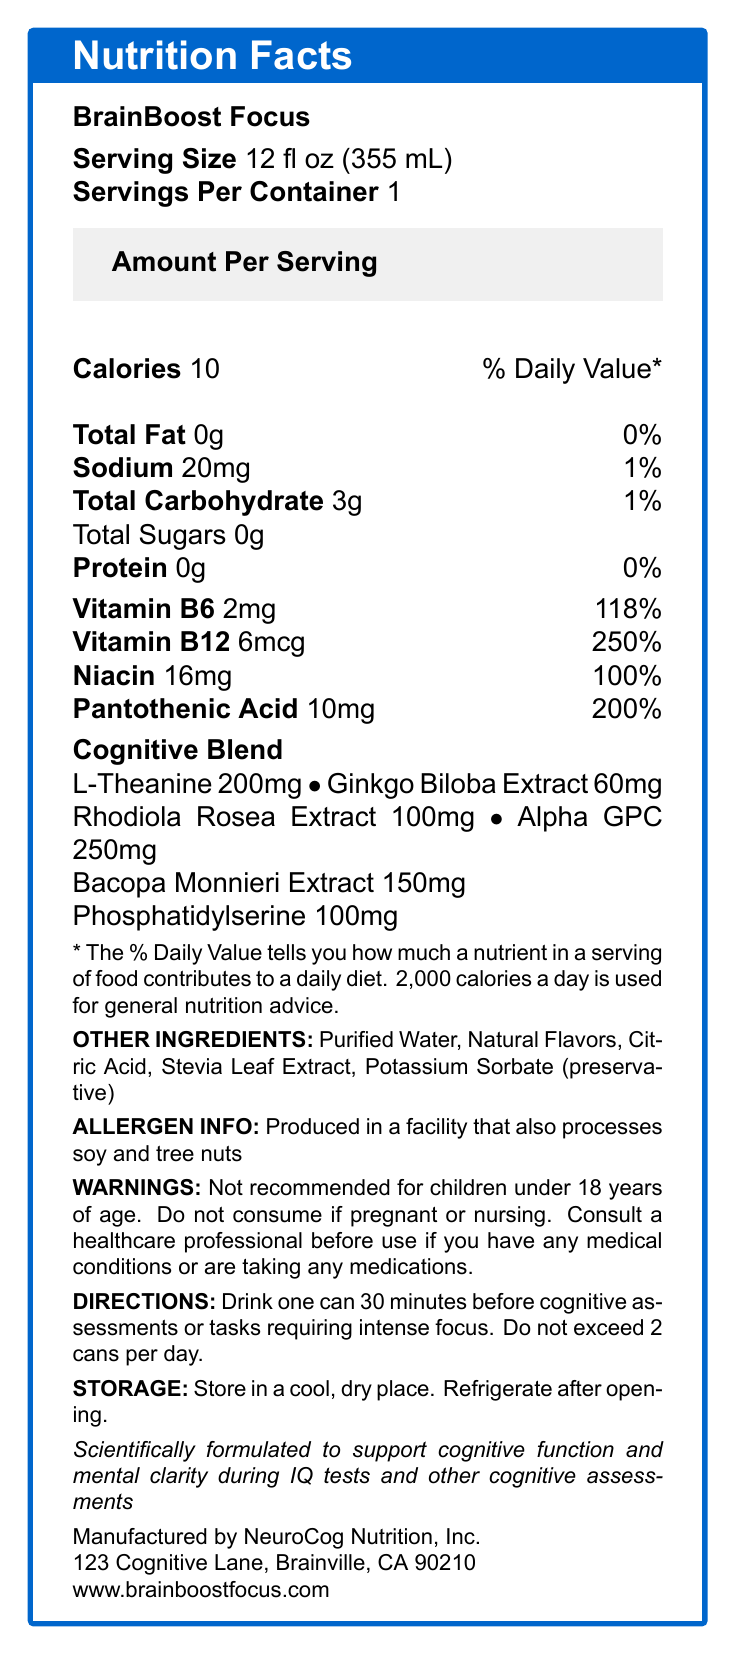what is the serving size? The serving size is clearly stated at the top of the nutrition facts section as "Serving Size 12 fl oz (355 mL)."
Answer: 12 fl oz (355 mL) how many calories are in a serving? The document lists "Calories 10" under the "Amount Per Serving" section.
Answer: 10 what vitamins are included in BrainBoost Focus? The vitamins included are mentioned under their respective names in the nutrition facts.
Answer: Vitamin B6, Vitamin B12, Niacin, Pantothenic Acid how much sodium is in one serving? The nutrition facts section lists "Sodium 20mg."
Answer: 20mg how many grams of total sugars are in one serving? The document mentions "Total Sugars 0g" under the total carbohydrate section.
Answer: 0g what kind of extract is included in the cognitive blend? A. St. John's Wort B. Ginkgo Biloba C. Green Tea The cognitive blend includes "Ginkgo Biloba Extract" as listed in the document.
Answer: B what is the amount of L-Theanine in BrainBoost Focus? A. 60mg B. 100mg C. 200mg The document mentions "L-Theanine 200mg" in the cognitive blend.
Answer: C what is one of the primary functional claims of the product? This claim is stated at the end of the nutrition facts box.
Answer: Scientifically formulated to support cognitive function and mental clarity during IQ tests and other cognitive assessments are there any allergens in BrainBoost Focus? The nutrition facts label states, "Produced in a facility that also processes soy and tree nuts."
Answer: Yes how many cans of the product can you consume in one day? The directions clearly state, "Do not exceed 2 cans per day."
Answer: 2 what is the recommended age for consuming BrainBoost Focus? The warning mentions, "Not recommended for children under 18 years of age."
Answer: Over 18 years of age is BrainBoost Focus recommended for pregnant women? The warnings section states, "Do not consume if pregnant or nursing."
Answer: No describe the directions for consuming BrainBoost Focus The document provides clear directions on when and how much of the product should be consumed.
Answer: Drink one can 30 minutes before cognitive assessments or tasks requiring intense focus. Do not exceed 2 cans per day. what is the purpose of the product BrainBoost Focus, based on the provided information? The purpose is indicated by the claim that it is "Scientifically formulated to support cognitive function and mental clarity during IQ tests and other cognitive assessments."
Answer: support cognitive function and mental clarity during IQ tests and other cognitive assessments what is the daily value percentage of Pantothenic Acid in one serving? The document states, "Pantothenic Acid 10mg 200%."
Answer: 200% how should BrainBoost Focus be stored after opening? The storage instructions provide this information.
Answer: Refrigerate after opening. who manufactures BrainBoost Focus? This information is listed at the bottom of the document.
Answer: NeuroCog Nutrition, Inc. what is one of the primary flavoring agents in BrainBoost Focus? This is listed under "Other Ingredients."
Answer: Natural Flavors what specific cognitive assessments are mentioned in the directions for consuming BrainBoost Focus? The directions mention "cognitive assessments or tasks requiring intense focus," but do not specify any particular assessments.
Answer: Not specified would you recommend BrainBoost Focus to someone who is taking medication without knowing their medical history? The warnings suggest consulting a healthcare professional if you have any medical conditions or are taking any medications.
Answer: No 